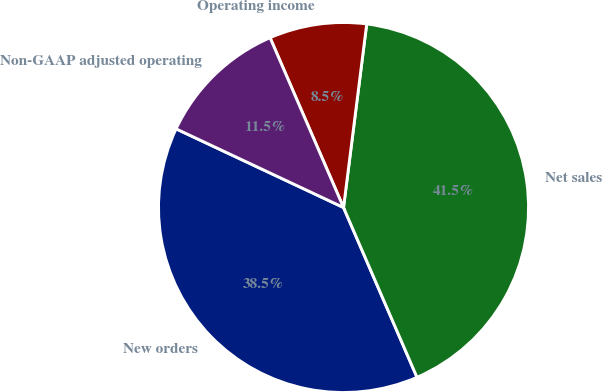Convert chart to OTSL. <chart><loc_0><loc_0><loc_500><loc_500><pie_chart><fcel>New orders<fcel>Net sales<fcel>Operating income<fcel>Non-GAAP adjusted operating<nl><fcel>38.49%<fcel>41.5%<fcel>8.5%<fcel>11.51%<nl></chart> 